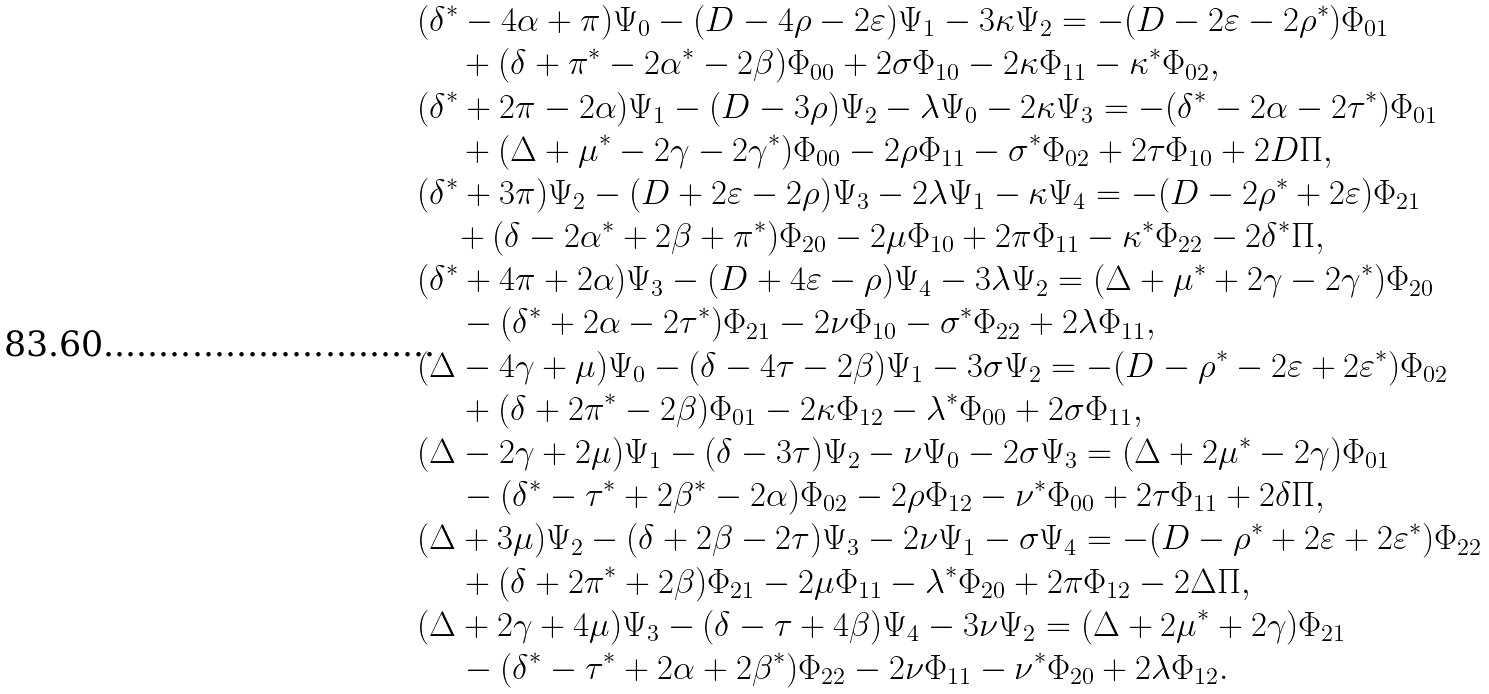<formula> <loc_0><loc_0><loc_500><loc_500>& ( \delta ^ { \ast } - 4 \alpha + \pi ) \Psi _ { 0 } - ( D - 4 \rho - 2 \varepsilon ) \Psi _ { 1 } - 3 \kappa \Psi _ { 2 } = - ( D - 2 \varepsilon - 2 \rho ^ { \ast } ) \Phi _ { 0 1 } \\ & \quad \, + ( \delta + \pi ^ { \ast } - 2 \alpha ^ { \ast } - 2 \beta ) \Phi _ { 0 0 } + 2 \sigma \Phi _ { 1 0 } - 2 \kappa \Phi _ { 1 1 } - \kappa ^ { \ast } \Phi _ { 0 2 } , \\ & ( \delta ^ { \ast } + 2 \pi - 2 \alpha ) \Psi _ { 1 } - ( D - 3 \rho ) \Psi _ { 2 } - \lambda \Psi _ { 0 } - 2 \kappa \Psi _ { 3 } = - ( \delta ^ { \ast } - 2 \alpha - 2 \tau ^ { \ast } ) \Phi _ { 0 1 } \\ & \quad \, + ( \Delta + \mu ^ { \ast } - 2 \gamma - 2 \gamma ^ { \ast } ) \Phi _ { 0 0 } - 2 \rho \Phi _ { 1 1 } - \sigma ^ { \ast } \Phi _ { 0 2 } + 2 \tau \Phi _ { 1 0 } + 2 D \Pi , \\ & ( \delta ^ { \ast } + 3 \pi ) \Psi _ { 2 } - ( D + 2 \varepsilon - 2 \rho ) \Psi _ { 3 } - 2 \lambda \Psi _ { 1 } - \kappa \Psi _ { 4 } = - ( D - 2 \rho ^ { \ast } + 2 \varepsilon ) \Phi _ { 2 1 } \\ & \quad + ( \delta - 2 \alpha ^ { \ast } + 2 \beta + \pi ^ { \ast } ) \Phi _ { 2 0 } - 2 \mu \Phi _ { 1 0 } + 2 \pi \Phi _ { 1 1 } - \kappa ^ { \ast } \Phi _ { 2 2 } - 2 \delta ^ { \ast } \Pi , \\ & ( \delta ^ { \ast } + 4 \pi + 2 \alpha ) \Psi _ { 3 } - ( D + 4 \varepsilon - \rho ) \Psi _ { 4 } - 3 \lambda \Psi _ { 2 } = ( \Delta + \mu ^ { \ast } + 2 \gamma - 2 \gamma ^ { \ast } ) \Phi _ { 2 0 } \\ & \quad \, - ( \delta ^ { \ast } + 2 \alpha - 2 \tau ^ { \ast } ) \Phi _ { 2 1 } - 2 \nu \Phi _ { 1 0 } - \sigma ^ { \ast } \Phi _ { 2 2 } + 2 \lambda \Phi _ { 1 1 } , \\ & ( \Delta - 4 \gamma + \mu ) \Psi _ { 0 } - ( \delta - 4 \tau - 2 \beta ) \Psi _ { 1 } - 3 \sigma \Psi _ { 2 } = - ( D - \rho ^ { \ast } - 2 \varepsilon + 2 \varepsilon ^ { \ast } ) \Phi _ { 0 2 } \\ & \quad \, + ( \delta + 2 \pi ^ { \ast } - 2 \beta ) \Phi _ { 0 1 } - 2 \kappa \Phi _ { 1 2 } - \lambda ^ { \ast } \Phi _ { 0 0 } + 2 \sigma \Phi _ { 1 1 } , \\ & ( \Delta - 2 \gamma + 2 \mu ) \Psi _ { 1 } - ( \delta - 3 \tau ) \Psi _ { 2 } - \nu \Psi _ { 0 } - 2 \sigma \Psi _ { 3 } = ( \Delta + 2 \mu ^ { \ast } - 2 \gamma ) \Phi _ { 0 1 } \\ & \quad \, - ( \delta ^ { \ast } - \tau ^ { \ast } + 2 \beta ^ { \ast } - 2 \alpha ) \Phi _ { 0 2 } - 2 \rho \Phi _ { 1 2 } - \nu ^ { \ast } \Phi _ { 0 0 } + 2 \tau \Phi _ { 1 1 } + 2 \delta \Pi , \\ & ( \Delta + 3 \mu ) \Psi _ { 2 } - ( \delta + 2 \beta - 2 \tau ) \Psi _ { 3 } - 2 \nu \Psi _ { 1 } - \sigma \Psi _ { 4 } = - ( D - \rho ^ { \ast } + 2 \varepsilon + 2 \varepsilon ^ { \ast } ) \Phi _ { 2 2 } \\ & \quad \, + ( \delta + 2 \pi ^ { \ast } + 2 \beta ) \Phi _ { 2 1 } - 2 \mu \Phi _ { 1 1 } - \lambda ^ { \ast } \Phi _ { 2 0 } + 2 \pi \Phi _ { 1 2 } - 2 \Delta \Pi , \\ & ( \Delta + 2 \gamma + 4 \mu ) \Psi _ { 3 } - ( \delta - \tau + 4 \beta ) \Psi _ { 4 } - 3 \nu \Psi _ { 2 } = ( \Delta + 2 \mu ^ { \ast } + 2 \gamma ) \Phi _ { 2 1 } \\ & \quad \, - ( \delta ^ { \ast } - \tau ^ { \ast } + 2 \alpha + 2 \beta ^ { \ast } ) \Phi _ { 2 2 } - 2 \nu \Phi _ { 1 1 } - \nu ^ { \ast } \Phi _ { 2 0 } + 2 \lambda \Phi _ { 1 2 } . \\</formula> 